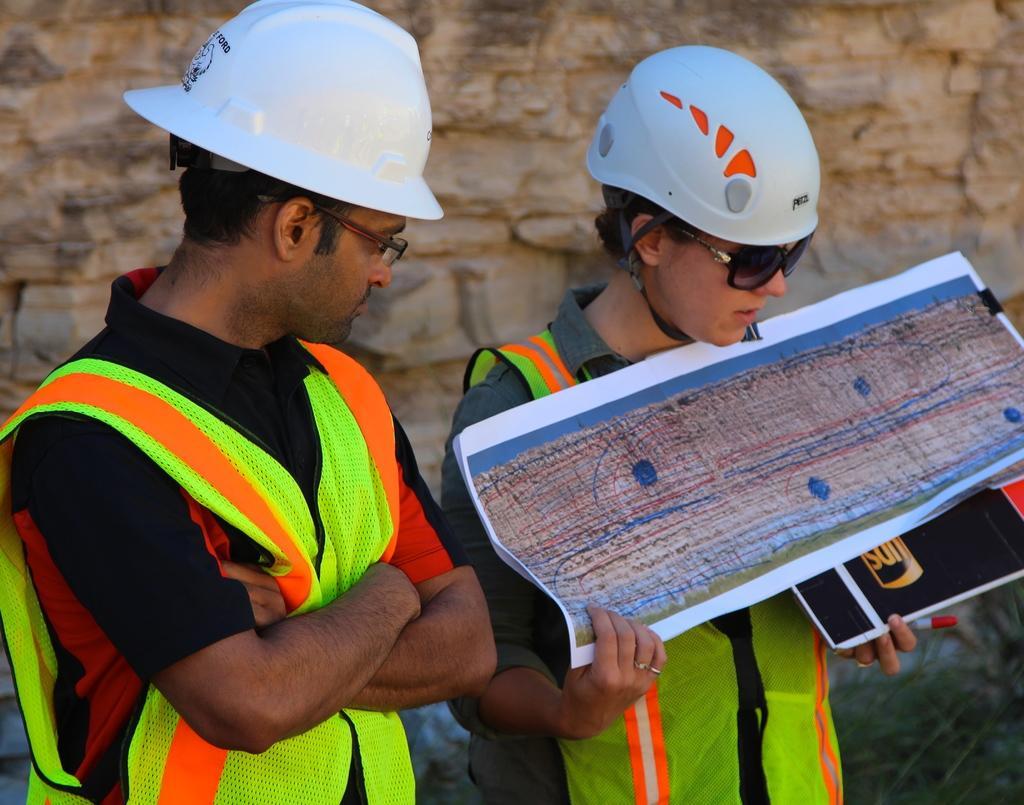Please provide a concise description of this image. This is the man and woman standing. They wore helmets, goggles and jackets. This woman is holding a book and a paper in her hands. In the background, that looks like a hill. 